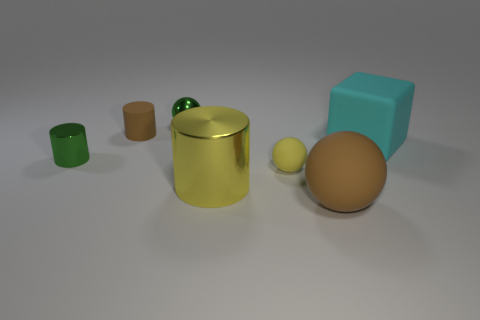Are there fewer green things that are in front of the large yellow shiny cylinder than spheres?
Give a very brief answer. Yes. How many tiny green cylinders are there?
Provide a short and direct response. 1. What is the shape of the small matte object that is to the left of the small thing behind the matte cylinder?
Offer a terse response. Cylinder. How many green things are in front of the small matte cylinder?
Your response must be concise. 1. Is the material of the tiny green ball the same as the thing in front of the large yellow cylinder?
Keep it short and to the point. No. Is there a cyan block that has the same size as the yellow metallic thing?
Your answer should be very brief. Yes. Are there an equal number of matte cylinders left of the large yellow metallic cylinder and cyan things?
Offer a terse response. Yes. How big is the rubber cube?
Provide a short and direct response. Large. What number of brown rubber cylinders are in front of the small sphere that is to the left of the yellow matte ball?
Provide a short and direct response. 1. The thing that is both in front of the tiny brown rubber cylinder and left of the green metal sphere has what shape?
Your answer should be very brief. Cylinder. 